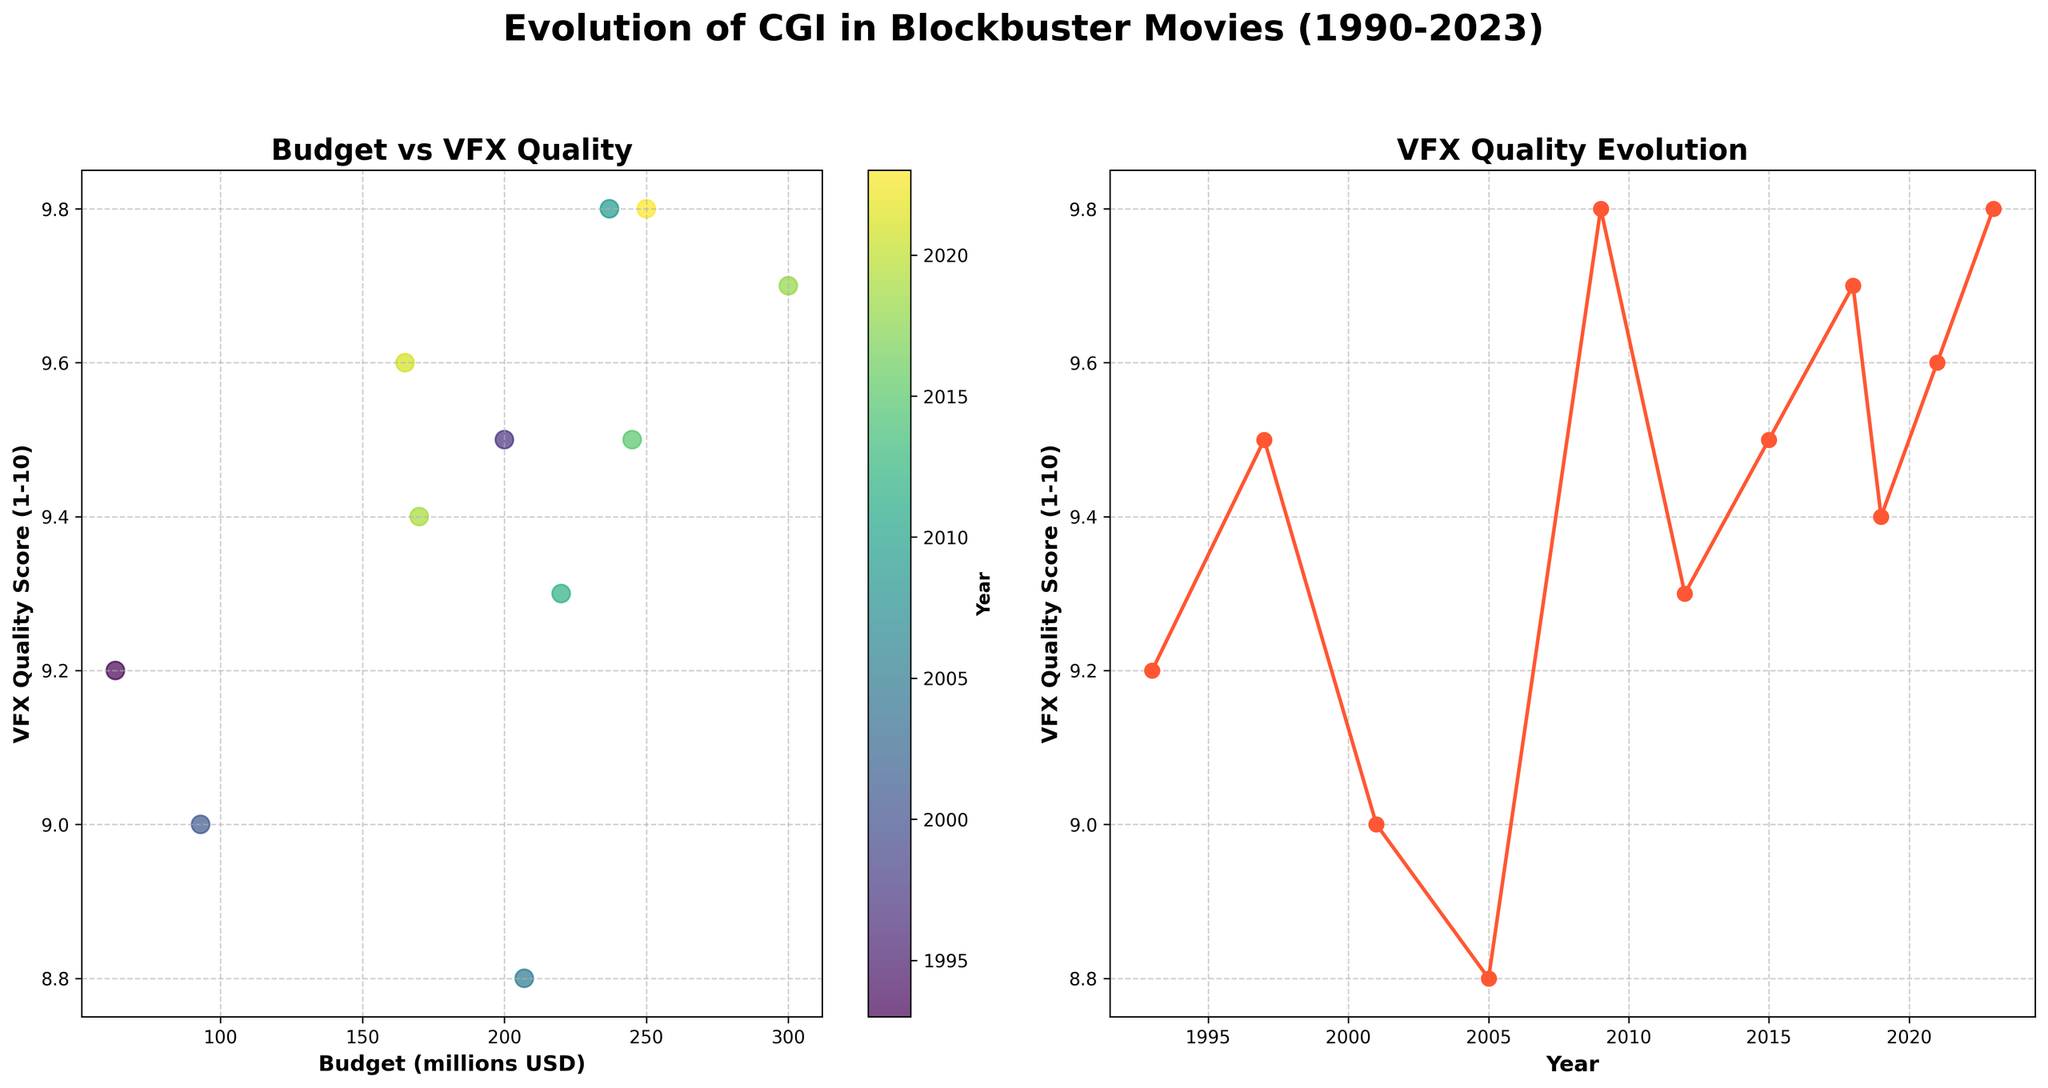What is the title of the scatter plot on the left side? The title of the scatter plot is typically located at the top of the subplot area. In this case, the title reads "Budget vs VFX Quality".
Answer: Budget vs VFX Quality What does the color bar represent in the scatter plot? The color bar in a scatter plot usually provides additional contextual information about the data points. Here, the label on the color bar indicates it represents the "Year".
Answer: Year Which movie has the highest budget according to the scatter plot? To identify the movie with the highest budget, we look for the data point on the scatter plot with the highest x-axis value. The x-axis represents the budget in millions of USD. "Avengers: Infinity War" at 300 million USD seems to have the highest budget.
Answer: Avengers: Infinity War What trend can be observed in the VFX Quality Score over the years from the line plot? Observing the line plot on the right, which depicts VFX Quality Score over the years, we see that the VFX Quality Scores have generally increased over time, indicating an upward trend.
Answer: Upward trend What is the relationship between budget and VFX Quality Score? By examining the scatter plot on the left, one can infer the relationship between budget and VFX Quality Score. The majority of higher-budget movies tend to have higher VFX Quality Scores, suggesting a positive correlation.
Answer: Positive correlation Which movies have almost equal VFX Quality Scores despite different budgets? By looking at the scatter plot, identify data points that are close vertically (Y-axis, VFX Quality Score) but distant horizontally (X-axis, budget). "Titanic" and "Dune" have similar VFX Quality Scores of 9.5 and 9.6 respectively, but their budgets are 200 and 165 million USD respectively.
Answer: Titanic and Dune How has the budget trend changed for blockbuster movies from 1990 to 2023? Examining the scatter plot, we can track the budgets over the years represented by different colors. We see an overall increase in budget, reflecting a general upward trend in movie production costs.
Answer: Increased What is the general VFX Quality Score for movies with a budget over 200 million USD? Looking at the scatter plot, we can identify movies with budgets over 200 million USD. These movies include "Titanic", "King Kong", "Avatar", "The Avengers", "Star Wars: The Force Awakens", "Avengers: Infinity War", and "Guardians of the Galaxy Vol. 3", all of which have high VFX Quality Scores above 9.
Answer: Above 9 What does the line connecting the points on the right plot indicate about the years 2005 to 2023? The line plot shows the progression of VFX Quality Scores over time. From 2005 to 2023, the line mostly trends upwards with minor fluctuations, indicating an overall consistent improvement in VFX quality.
Answer: Consistent improvement 